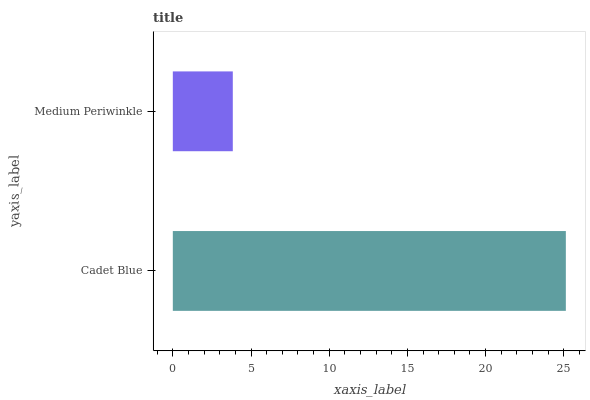Is Medium Periwinkle the minimum?
Answer yes or no. Yes. Is Cadet Blue the maximum?
Answer yes or no. Yes. Is Medium Periwinkle the maximum?
Answer yes or no. No. Is Cadet Blue greater than Medium Periwinkle?
Answer yes or no. Yes. Is Medium Periwinkle less than Cadet Blue?
Answer yes or no. Yes. Is Medium Periwinkle greater than Cadet Blue?
Answer yes or no. No. Is Cadet Blue less than Medium Periwinkle?
Answer yes or no. No. Is Cadet Blue the high median?
Answer yes or no. Yes. Is Medium Periwinkle the low median?
Answer yes or no. Yes. Is Medium Periwinkle the high median?
Answer yes or no. No. Is Cadet Blue the low median?
Answer yes or no. No. 